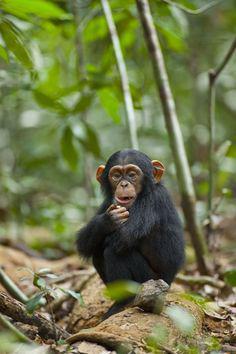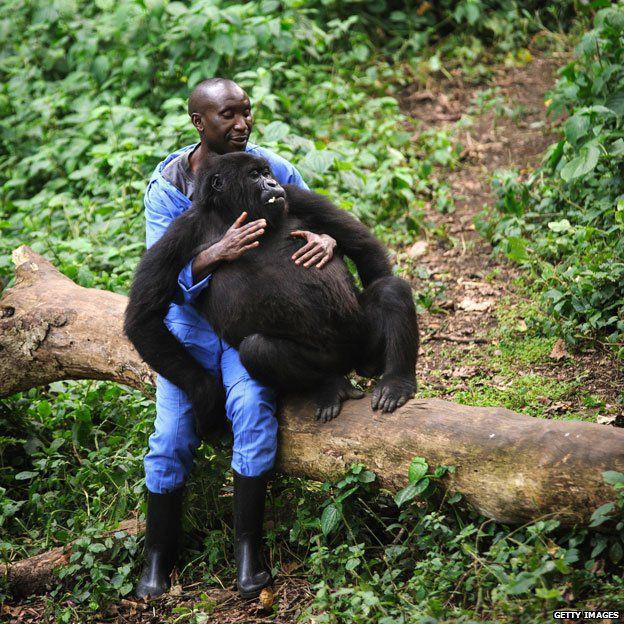The first image is the image on the left, the second image is the image on the right. For the images displayed, is the sentence "An image contains a human interacting with a chimpanzee." factually correct? Answer yes or no. Yes. The first image is the image on the left, the second image is the image on the right. Given the left and right images, does the statement "In one image, a person is interacting with a chimpanzee, while a second image shows a chimp sitting with its knees drawn up and arms resting on them." hold true? Answer yes or no. Yes. 